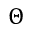<formula> <loc_0><loc_0><loc_500><loc_500>\Theta</formula> 